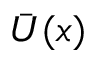<formula> <loc_0><loc_0><loc_500><loc_500>\bar { U } ( x )</formula> 